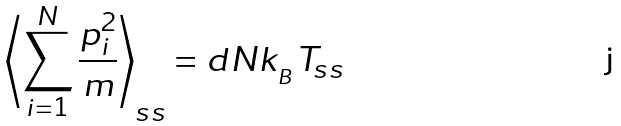<formula> <loc_0><loc_0><loc_500><loc_500>\left \langle \sum _ { i = 1 } ^ { N } \frac { { p } _ { i } ^ { 2 } } { m } \right \rangle _ { s s } = d N k _ { _ { B } } T _ { s s }</formula> 